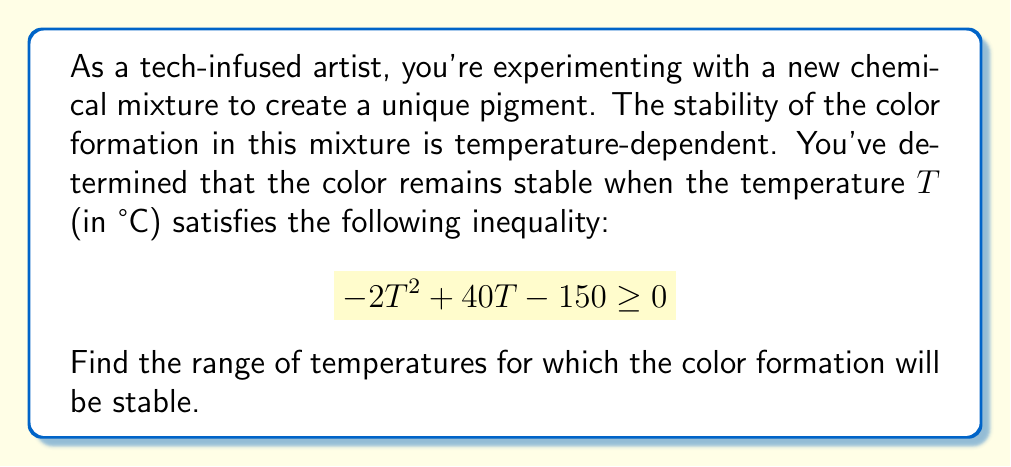Provide a solution to this math problem. To solve this problem, we need to find the values of $T$ that satisfy the given quadratic inequality. Let's approach this step-by-step:

1) First, we need to find the roots of the quadratic equation $-2T^2 + 40T - 150 = 0$. We can do this using the quadratic formula: $T = \frac{-b \pm \sqrt{b^2 - 4ac}}{2a}$

   Where $a = -2$, $b = 40$, and $c = -150$

2) Substituting these values:

   $T = \frac{-40 \pm \sqrt{40^2 - 4(-2)(-150)}}{2(-2)}$

3) Simplifying:

   $T = \frac{-40 \pm \sqrt{1600 - 1200}}{-4} = \frac{-40 \pm \sqrt{400}}{-4} = \frac{-40 \pm 20}{-4}$

4) This gives us two roots:

   $T_1 = \frac{-40 + 20}{-4} = 5$ and $T_2 = \frac{-40 - 20}{-4} = 15$

5) Now, we need to determine where the inequality $-2T^2 + 40T - 150 \geq 0$ is satisfied. Since the coefficient of $T^2$ is negative, the parabola opens downward. This means the inequality is satisfied between the roots.

6) Therefore, the color formation will be stable for temperatures $T$ such that:

   $5 \leq T \leq 15$

This means the temperature range for stable color formation is from 5°C to 15°C, inclusive.
Answer: The temperature range for stable color formation is $[5, 15]$ °C, or $5 \leq T \leq 15$ °C. 